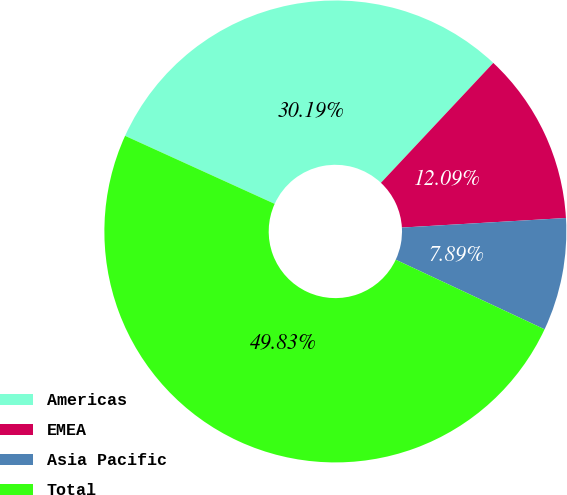Convert chart to OTSL. <chart><loc_0><loc_0><loc_500><loc_500><pie_chart><fcel>Americas<fcel>EMEA<fcel>Asia Pacific<fcel>Total<nl><fcel>30.19%<fcel>12.09%<fcel>7.89%<fcel>49.83%<nl></chart> 